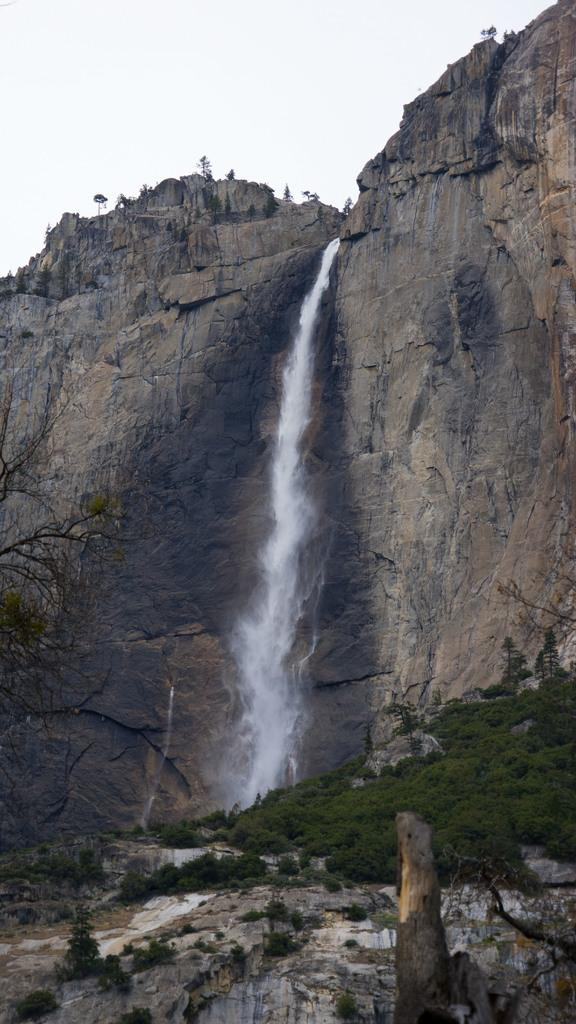What natural feature is the main subject of the image? There is a waterfall in the image. What type of vegetation is present in the image? There are trees in the image. What can be seen in the background of the image? The sky is visible in the image. What type of geological feature is present in the image? There are big rocks in the image. Where is the quicksand located in the image? There is no quicksand present in the image. What type of cake is being served at the waterfall in the image? There is no cake present in the image; it features a waterfall, trees, the sky, and big rocks. 